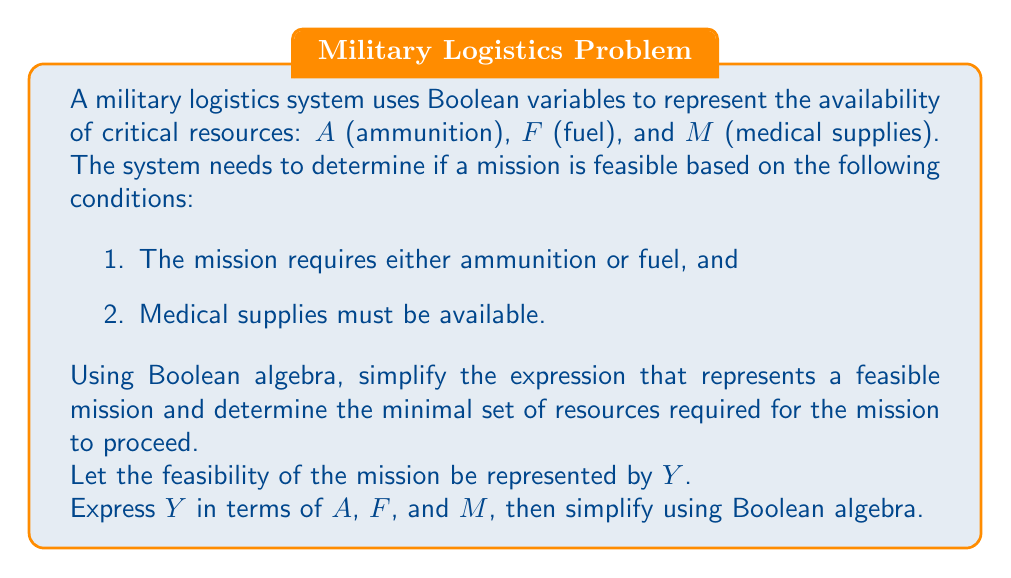Could you help me with this problem? Step 1: Express the mission feasibility (Y) in Boolean terms:
Y = (A OR F) AND M
In Boolean algebra notation: $Y = (A + F) \cdot M$

Step 2: Apply the distributive law to expand the expression:
$Y = (A \cdot M) + (F \cdot M)$

Step 3: Since this expression is already in its simplest form (sum of products), we cannot simplify it further.

Step 4: Interpret the result:
The mission is feasible (Y = 1) if either:
a) Ammunition (A) AND Medical supplies (M) are available, OR
b) Fuel (F) AND Medical supplies (M) are available.

Step 5: Determine the minimal set of resources:
The minimal set of resources must include Medical supplies (M) and either Ammunition (A) or Fuel (F).

This Boolean expression optimizes the decision-making process by clearly defining the minimum requirements for mission feasibility, allowing logistics planners to efficiently allocate resources.
Answer: $Y = (A \cdot M) + (F \cdot M)$; Minimal set: M and (A or F) 